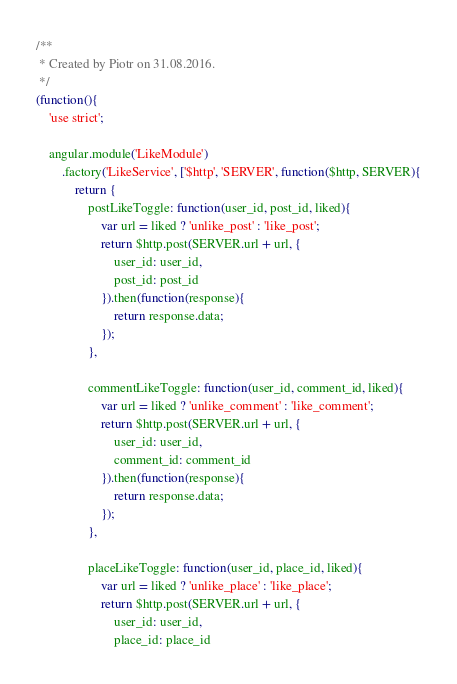<code> <loc_0><loc_0><loc_500><loc_500><_JavaScript_>/**
 * Created by Piotr on 31.08.2016.
 */
(function(){
    'use strict';

    angular.module('LikeModule')
        .factory('LikeService', ['$http', 'SERVER', function($http, SERVER){
            return {
                postLikeToggle: function(user_id, post_id, liked){
                    var url = liked ? 'unlike_post' : 'like_post';
                    return $http.post(SERVER.url + url, {
                        user_id: user_id,
                        post_id: post_id
                    }).then(function(response){
                        return response.data;
                    });
                },

                commentLikeToggle: function(user_id, comment_id, liked){
                    var url = liked ? 'unlike_comment' : 'like_comment';
                    return $http.post(SERVER.url + url, {
                        user_id: user_id,
                        comment_id: comment_id
                    }).then(function(response){
                        return response.data;
                    });
                },

                placeLikeToggle: function(user_id, place_id, liked){
                    var url = liked ? 'unlike_place' : 'like_place';
                    return $http.post(SERVER.url + url, {
                        user_id: user_id,
                        place_id: place_id</code> 